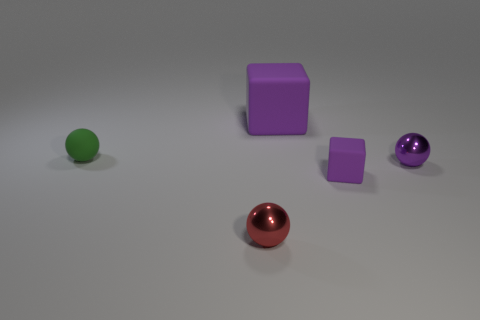Add 2 large cyan metallic things. How many objects exist? 7 Subtract all cubes. How many objects are left? 3 Subtract all cyan blocks. Subtract all purple metal balls. How many objects are left? 4 Add 4 green rubber spheres. How many green rubber spheres are left? 5 Add 5 small purple rubber cubes. How many small purple rubber cubes exist? 6 Subtract 0 red cylinders. How many objects are left? 5 